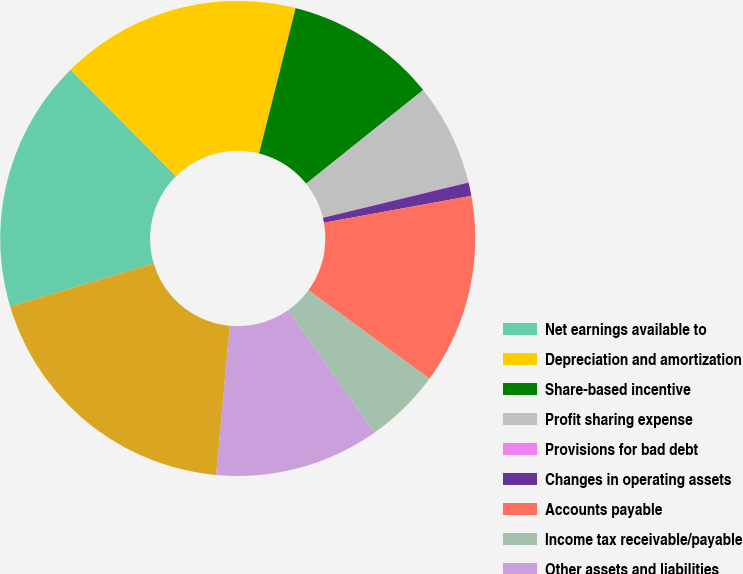Convert chart to OTSL. <chart><loc_0><loc_0><loc_500><loc_500><pie_chart><fcel>Net earnings available to<fcel>Depreciation and amortization<fcel>Share-based incentive<fcel>Profit sharing expense<fcel>Provisions for bad debt<fcel>Changes in operating assets<fcel>Accounts payable<fcel>Income tax receivable/payable<fcel>Other assets and liabilities<fcel>Net cash provided by operating<nl><fcel>17.2%<fcel>16.35%<fcel>10.34%<fcel>6.91%<fcel>0.05%<fcel>0.91%<fcel>12.92%<fcel>5.2%<fcel>11.2%<fcel>18.92%<nl></chart> 